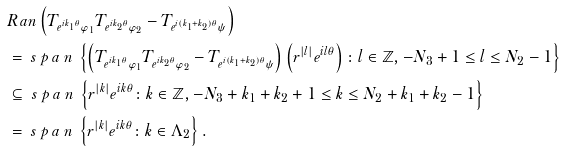Convert formula to latex. <formula><loc_0><loc_0><loc_500><loc_500>& R a n \left ( T _ { e ^ { i k _ { 1 } \theta } \varphi _ { 1 } } T _ { e ^ { i k _ { 2 } \theta } \varphi _ { 2 } } - T _ { e ^ { i ( k _ { 1 } + k _ { 2 } ) \theta } \psi } \right ) \\ & = \emph { s p a n } \left \{ \left ( T _ { e ^ { i k _ { 1 } \theta } \varphi _ { 1 } } T _ { e ^ { i k _ { 2 } \theta } \varphi _ { 2 } } - T _ { e ^ { i ( k _ { 1 } + k _ { 2 } ) \theta } \psi } \right ) \left ( r ^ { | l | } e ^ { i l \theta } \right ) \colon l \in { \mathbb { Z } } , - N _ { 3 } + 1 \leq l \leq N _ { 2 } - 1 \right \} \\ & \subseteq \emph { s p a n } \left \{ r ^ { | k | } e ^ { i k \theta } \colon k \in { \mathbb { Z } } , - N _ { 3 } + k _ { 1 } + k _ { 2 } + 1 \leq k \leq N _ { 2 } + k _ { 1 } + k _ { 2 } - 1 \right \} \\ & = \emph { s p a n } \left \{ r ^ { | k | } e ^ { i k \theta } \colon k \in { \Lambda _ { 2 } } \right \} .</formula> 